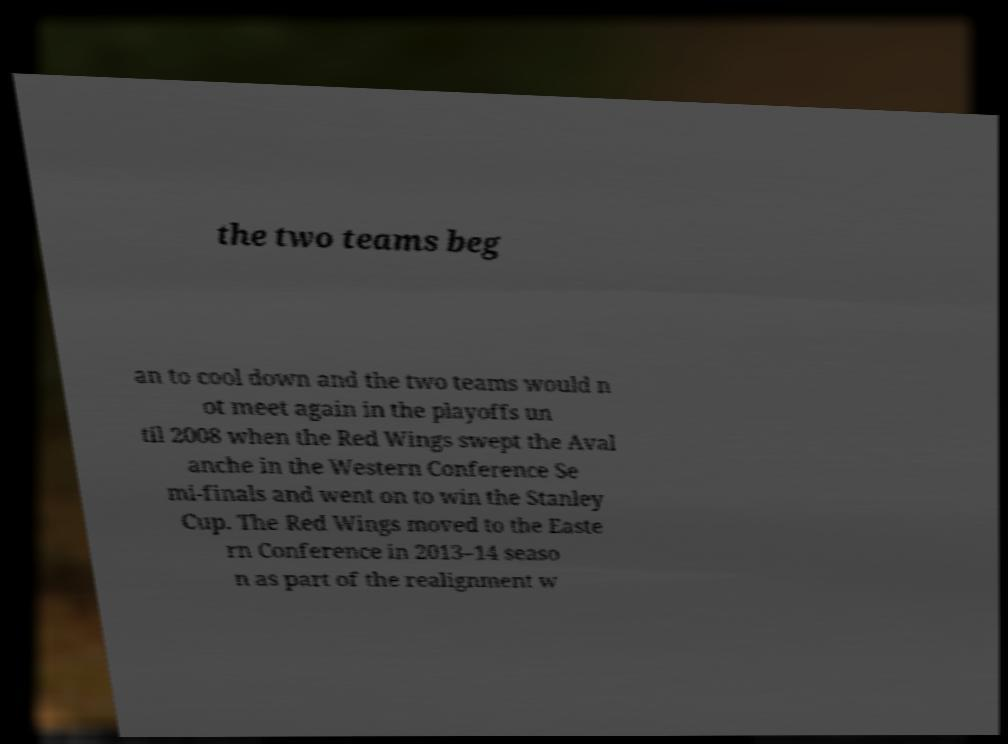I need the written content from this picture converted into text. Can you do that? the two teams beg an to cool down and the two teams would n ot meet again in the playoffs un til 2008 when the Red Wings swept the Aval anche in the Western Conference Se mi-finals and went on to win the Stanley Cup. The Red Wings moved to the Easte rn Conference in 2013–14 seaso n as part of the realignment w 